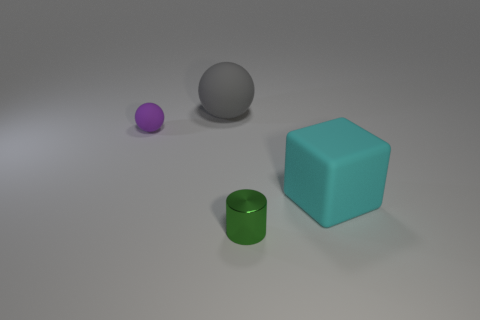Are there any big cyan matte things that have the same shape as the tiny purple object?
Your response must be concise. No. Are there the same number of small cylinders behind the green cylinder and tiny green balls?
Your answer should be very brief. Yes. There is a small object that is in front of the object that is right of the cylinder; what is it made of?
Provide a short and direct response. Metal. What shape is the cyan rubber object?
Provide a succinct answer. Cube. Is the number of balls that are right of the green cylinder the same as the number of rubber spheres to the right of the tiny purple ball?
Make the answer very short. No. Is the number of objects that are on the left side of the tiny metallic cylinder greater than the number of green shiny cylinders?
Offer a terse response. Yes. What is the shape of the cyan thing that is made of the same material as the gray sphere?
Ensure brevity in your answer.  Cube. There is a ball on the right side of the purple rubber thing; is it the same size as the tiny cylinder?
Keep it short and to the point. No. There is a tiny thing that is on the right side of the matte sphere that is in front of the big gray matte thing; what is its shape?
Make the answer very short. Cylinder. What size is the matte sphere that is in front of the big thing that is to the left of the cyan rubber cube?
Provide a succinct answer. Small. 